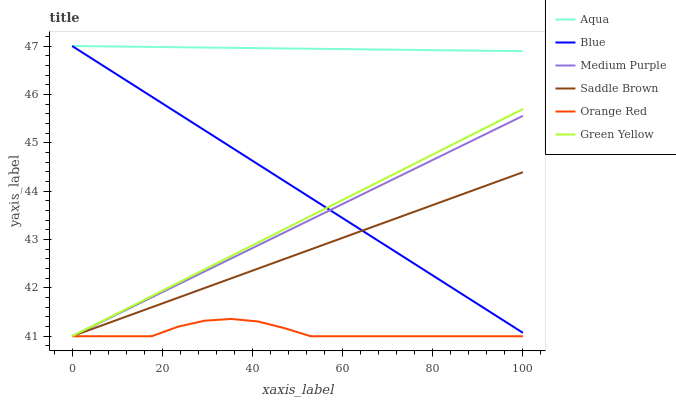Does Orange Red have the minimum area under the curve?
Answer yes or no. Yes. Does Aqua have the maximum area under the curve?
Answer yes or no. Yes. Does Aqua have the minimum area under the curve?
Answer yes or no. No. Does Orange Red have the maximum area under the curve?
Answer yes or no. No. Is Blue the smoothest?
Answer yes or no. Yes. Is Orange Red the roughest?
Answer yes or no. Yes. Is Aqua the smoothest?
Answer yes or no. No. Is Aqua the roughest?
Answer yes or no. No. Does Orange Red have the lowest value?
Answer yes or no. Yes. Does Aqua have the lowest value?
Answer yes or no. No. Does Aqua have the highest value?
Answer yes or no. Yes. Does Orange Red have the highest value?
Answer yes or no. No. Is Green Yellow less than Aqua?
Answer yes or no. Yes. Is Aqua greater than Orange Red?
Answer yes or no. Yes. Does Orange Red intersect Medium Purple?
Answer yes or no. Yes. Is Orange Red less than Medium Purple?
Answer yes or no. No. Is Orange Red greater than Medium Purple?
Answer yes or no. No. Does Green Yellow intersect Aqua?
Answer yes or no. No. 